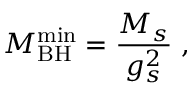<formula> <loc_0><loc_0><loc_500><loc_500>M _ { B H } ^ { \min } = \frac { M _ { s } } { g _ { s } ^ { 2 } } \, ,</formula> 